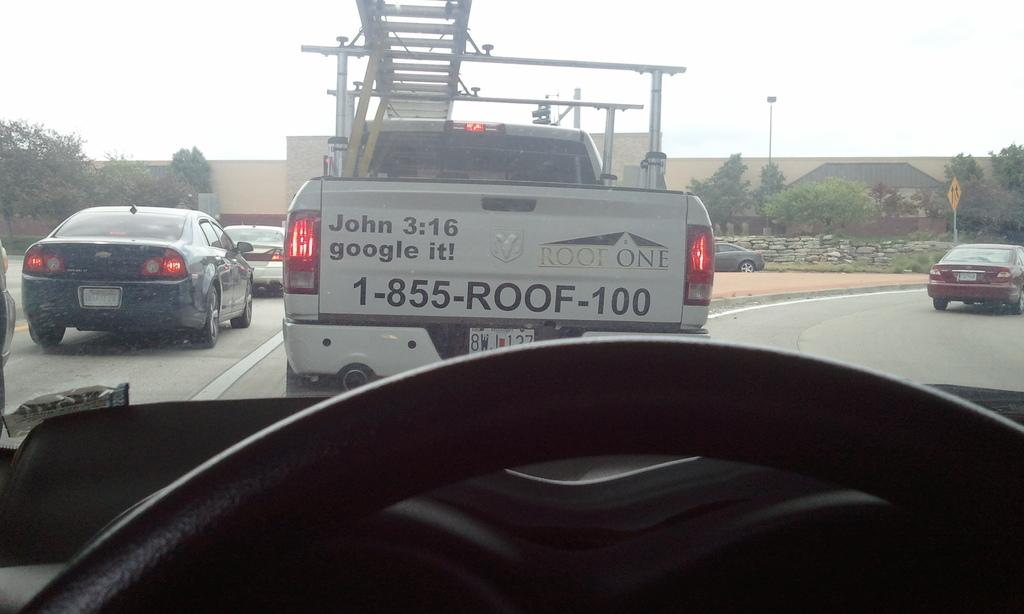What can be seen on the road in the image? There are vehicles on the road in the image. What is visible in the background of the image? There is a wall, a board, lights on poles, trees, and the sky visible in the background. What type of mouth can be seen on the bell in the image? There is no bell present in the image, so it is not possible to determine if it has a mouth or not. 